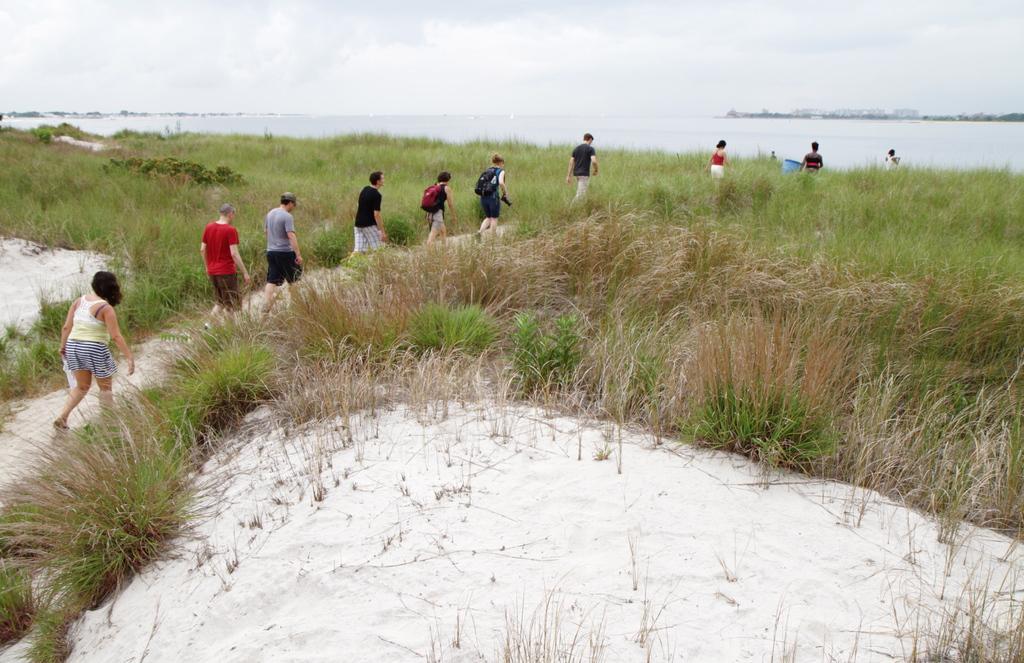How would you summarize this image in a sentence or two? In the center of the image we can see some persons are walking, some of them are carrying bags and holding camera, cloth. In the background of the image we can see water, plants. At the bottom of the image we can see sand. At the top of the image clouds are present in the sky. At the top right corner we can see trees, buildings. 